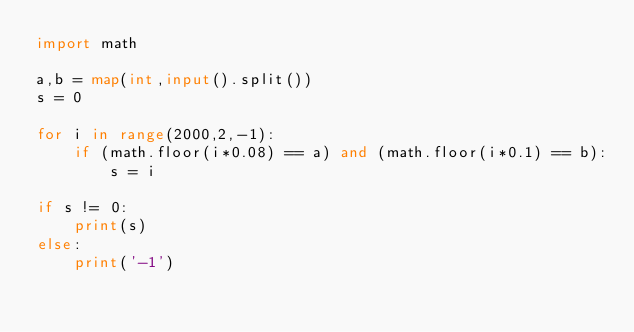Convert code to text. <code><loc_0><loc_0><loc_500><loc_500><_Python_>import math

a,b = map(int,input().split())
s = 0

for i in range(2000,2,-1):
    if (math.floor(i*0.08) == a) and (math.floor(i*0.1) == b):
        s = i

if s != 0:
    print(s)
else:
    print('-1')
</code> 